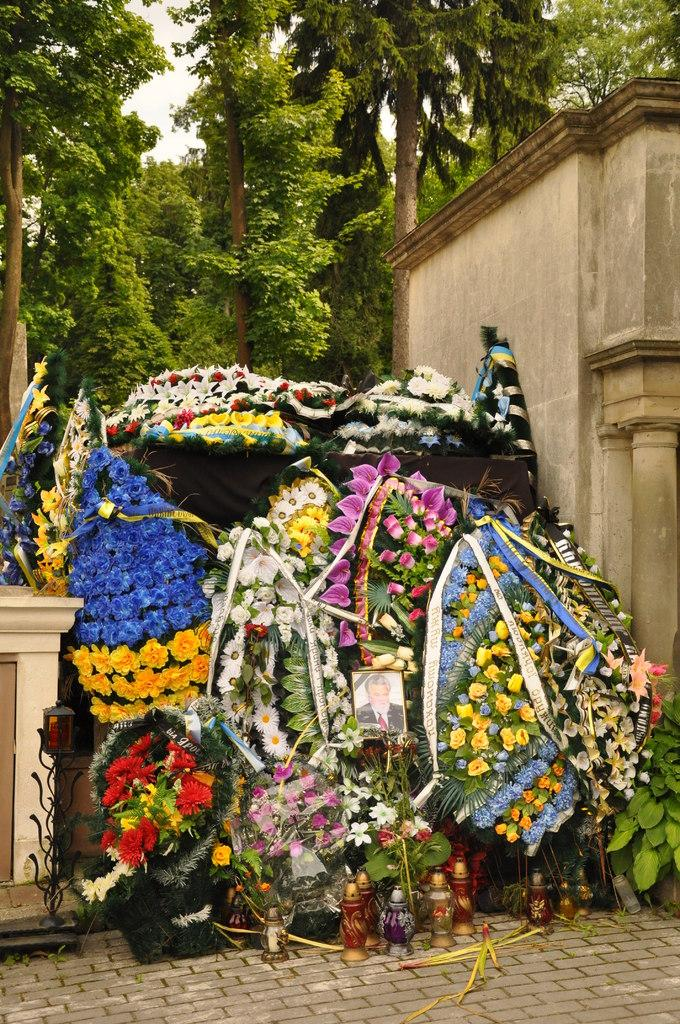What is the main subject of the image? The main subject of the image is many flower bouquets. Are there any additional elements on the flower bouquets? Yes, there is a photograph on the flower bouquets. What can be seen in the background of the image? There is a wall, trees, and the sky visible in the background of the image. How many people are swimming in the image? There is no swimming or people visible in the image; it features flower bouquets with a photograph and a background of a wall, trees, and the sky. 